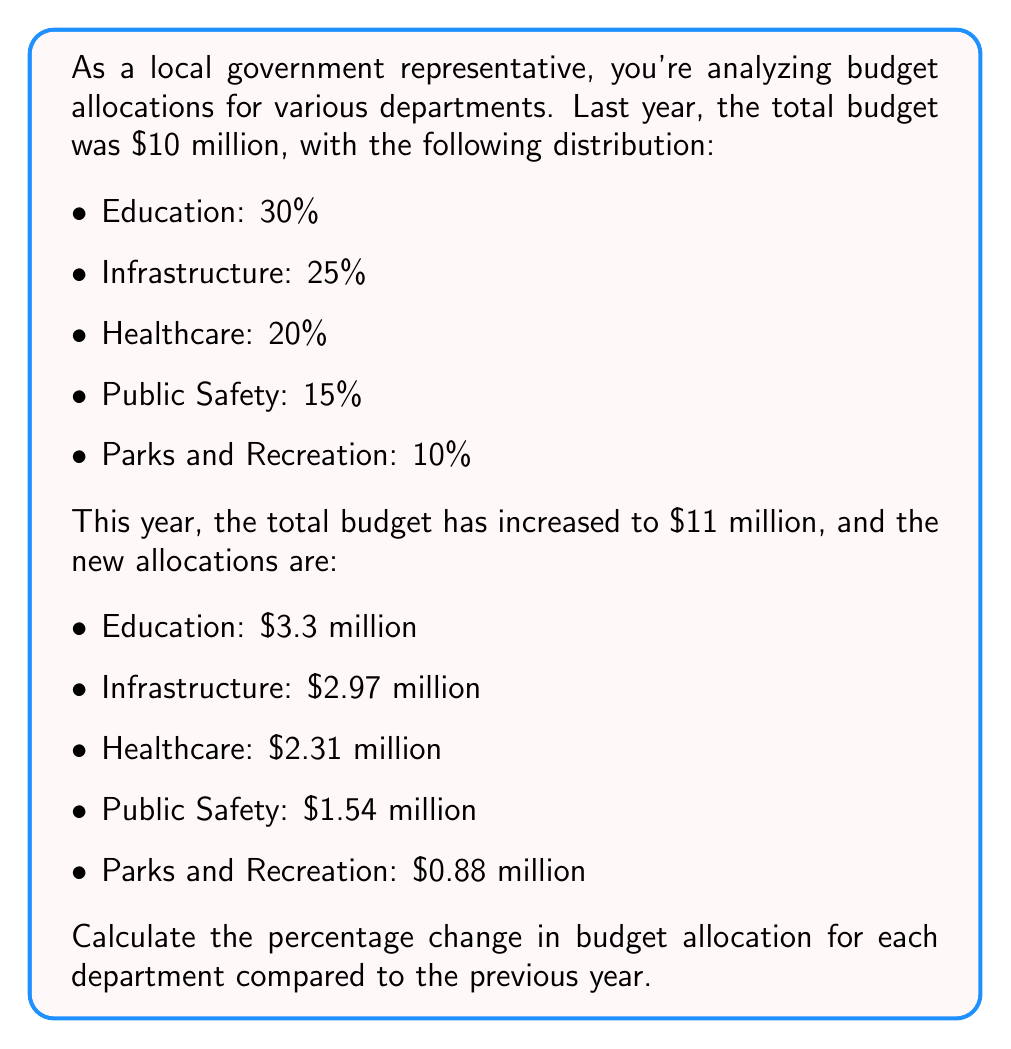Could you help me with this problem? To calculate the percentage change in budget allocation for each department, we'll follow these steps:

1. Calculate the previous year's allocation amount for each department.
2. Calculate the percentage change using the formula:
   $$\text{Percentage Change} = \frac{\text{New Value} - \text{Original Value}}{\text{Original Value}} \times 100\%$$

Let's go through each department:

1. Education:
   Previous allocation: $30\% \times \$10\text{ million} = \$3\text{ million}$
   New allocation: $\$3.3\text{ million}$
   Percentage change: $\frac{3.3 - 3}{3} \times 100\% = 10\%$

2. Infrastructure:
   Previous allocation: $25\% \times \$10\text{ million} = \$2.5\text{ million}$
   New allocation: $\$2.97\text{ million}$
   Percentage change: $\frac{2.97 - 2.5}{2.5} \times 100\% = 18.8\%$

3. Healthcare:
   Previous allocation: $20\% \times \$10\text{ million} = \$2\text{ million}$
   New allocation: $\$2.31\text{ million}$
   Percentage change: $\frac{2.31 - 2}{2} \times 100\% = 15.5\%$

4. Public Safety:
   Previous allocation: $15\% \times \$10\text{ million} = \$1.5\text{ million}$
   New allocation: $\$1.54\text{ million}$
   Percentage change: $\frac{1.54 - 1.5}{1.5} \times 100\% = 2.67\%$

5. Parks and Recreation:
   Previous allocation: $10\% \times \$10\text{ million} = \$1\text{ million}$
   New allocation: $\$0.88\text{ million}$
   Percentage change: $\frac{0.88 - 1}{1} \times 100\% = -12\%$
Answer: The percentage changes in budget allocation for each department are:

Education: $+10\%$
Infrastructure: $+18.8\%$
Healthcare: $+15.5\%$
Public Safety: $+2.67\%$
Parks and Recreation: $-12\%$ 